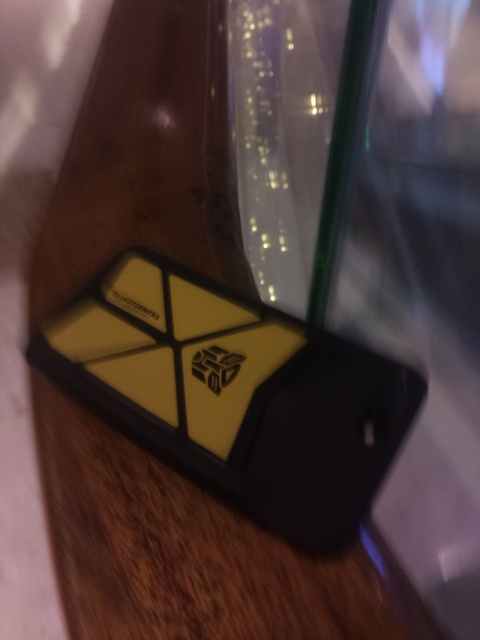What is the object in the image and does it seem to be in its usual position? The image depicts a phone lying on its back, resting against a surface. It's not in its typical upright position as one would expect when in use. Large, visible icons suggest a personalized case or a special edition design, which adds a distinctive character to the device. 